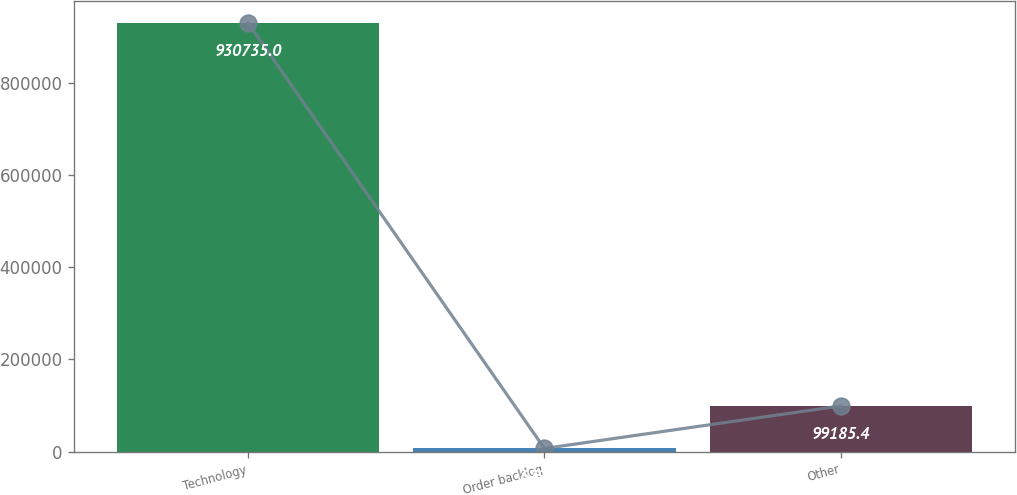<chart> <loc_0><loc_0><loc_500><loc_500><bar_chart><fcel>Technology<fcel>Order backlog<fcel>Other<nl><fcel>930735<fcel>6791<fcel>99185.4<nl></chart> 